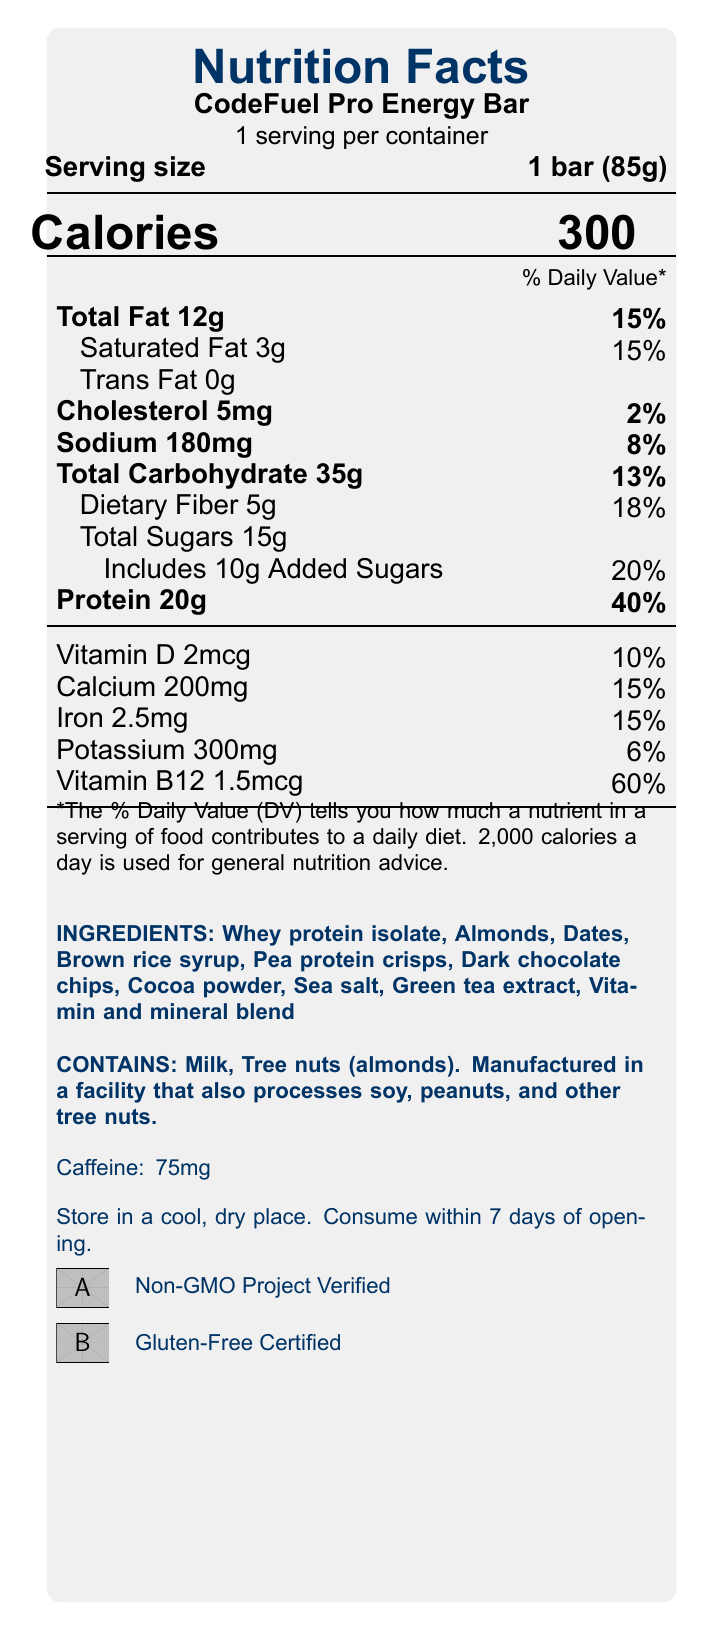What is the serving size of the CodeFuel Pro Energy Bar? The serving size is explicitly listed as "1 bar (85g)" in the document.
Answer: 1 bar (85g) How many calories are in one serving of the CodeFuel Pro Energy Bar? The document lists "Calories 300" prominently within the nutritional facts section.
Answer: 300 What percentage of the daily value of protein does one serving of the bar provide? The document indicates that the protein content is 20g, which corresponds to 40% of the daily value.
Answer: 40% How much dietary fiber is in the CodeFuel Pro Energy Bar? The nutritional facts include "Dietary Fiber 5g" as part of the total carbohydrate breakdown.
Answer: 5g Does the CodeFuel Pro Energy Bar contain any trans fat? The document states "Trans Fat 0g" indicating there is no trans fat.
Answer: No Which of the following is an allergen present in the CodeFuel Pro Energy Bar? 
A. Soy
B. Peanuts
C. Milk
D. Wheat The document's allergen statement lists "Contains milk and tree nuts (almonds)".
Answer: C. Milk What is the amount of sodium in one serving, and how much of the daily value does it represent?
A. 100mg, 4%
B. 180mg, 8%
C. 200mg, 10%
D. 150mg, 6% The document states "Sodium 180mg" which constitutes 8% of the daily value.
Answer: B. 180mg, 8% Does the CodeFuel Pro Energy Bar contain any added sugars? The document lists "Includes 10g Added Sugars" which is 20% of the daily value.
Answer: Yes What is the main purpose of the developer benefits listed in the document? The developer benefits mention aspects like sustained energy release, high protein content for mental focus, carbohydrates for quick energy, added caffeine for alertness, B vitamins for cognitive function, and antioxidants to combat stress.
Answer: To support developers with sustained energy, mental focus, and alertness during long coding sessions. How much Vitamin B12 is in the CodeFuel Pro Energy Bar? The nutritional information section lists "Vitamin B12 1.5mcg" which is 60% of the daily value.
Answer: 1.5mcg Does the CodeFuel Pro Energy Bar come in a container with multiple servings? The document states "1 serving per container," indicating it is a single-serving product.
Answer: No What certifications does the CodeFuel Pro Energy Bar have? The document contains logos and text indicating "Non-GMO Project Verified" and "Gluten-Free Certified".
Answer: Non-GMO Project Verified and Gluten-Free Certified Summarize the nutritional content and unique benefits of the CodeFuel Pro Energy Bar. This summary captures the core nutritional details along with the developer-specific benefits and certifications.
Answer: The CodeFuel Pro Energy Bar provides 300 calories per serving with significant protein content (20g, 40% DV), 35g total carbohydrates, 12g total fat, and 5g dietary fiber. It includes key vitamins and minerals, added caffeine for alertness, and specific benefits for developers, such as sustained energy and mental focus. It is verified as Non-GMO and certified gluten-free. What percentage of the daily value of calcium does the CodeFuel Pro Energy Bar provide? The document specifies "Calcium 200mg," which accounts for 15% of the daily value.
Answer: 15% What is the total amount of sugars including added sugars? The document lists "Total Sugars 15g" and specifies "Includes 10g Added Sugars".
Answer: 15g total sugars, with 10g added sugars Where should the CodeFuel Pro Energy Bar be stored once opened? The storage instructions section advises storing in a cool, dry place and consuming within 7 days of opening.
Answer: In a cool, dry place. What is the carbohydrate content of the CodeFuel Pro Energy Bar? The nutritional facts state "Total Carbohydrate 35g," which includes dietary fiber and sugars.
Answer: 35g Does the CodeFuel Pro Energy Bar contain any tree nuts? The allergen statement mentions "Tree nuts (almonds)".
Answer: Yes What is the iron content in one serving? The document lists "Iron 2.5mg," which constitutes 15% of the daily value.
Answer: 2.5mg How much added sugar does the CodeFuel Pro Energy Bar include? The document specifically mentions "Includes 10g Added Sugars".
Answer: 10g What specific antioxidants are mentioned in the developer benefits section? The developer benefits section highlights antioxidants from dark chocolate as beneficial.
Answer: Dark chocolate What are all the ingredients in the CodeFuel Pro Energy Bar? The document lists several ingredients but indicates there is also a "vitamin and mineral blend" which is unspecified.
Answer: Cannot be determined Does the CodeFuel Pro Energy Bar contain caffeine? The document states "Caffeine: 75mg."
Answer: Yes Is the energy bar gluten-free? The document is certified as "Gluten-Free," indicating it contains no gluten.
Answer: Yes 